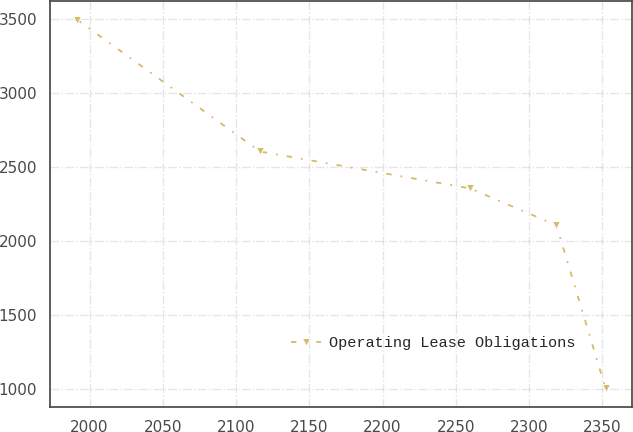Convert chart to OTSL. <chart><loc_0><loc_0><loc_500><loc_500><line_chart><ecel><fcel>Operating Lease Obligations<nl><fcel>1991.36<fcel>3499.73<nl><fcel>2116.27<fcel>2607.4<nl><fcel>2259.54<fcel>2358.01<nl><fcel>2318.66<fcel>2108.62<nl><fcel>2352.15<fcel>1005.79<nl></chart> 